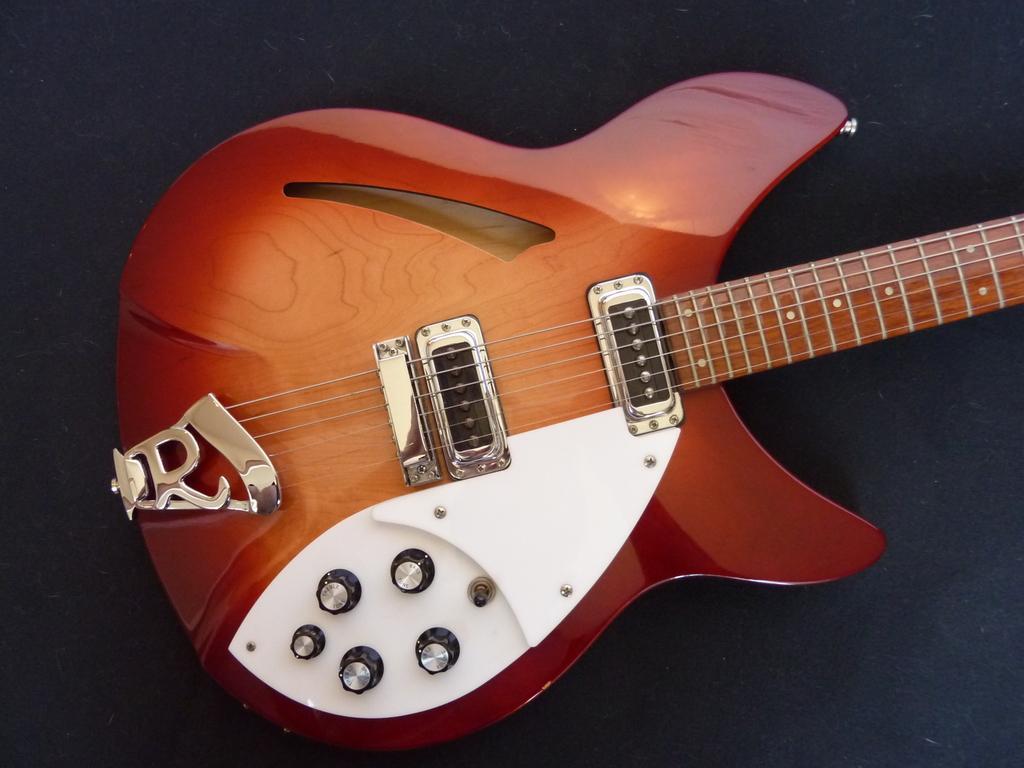Describe this image in one or two sentences. In the image in the center, we can see one guitar, which is in brown color. 